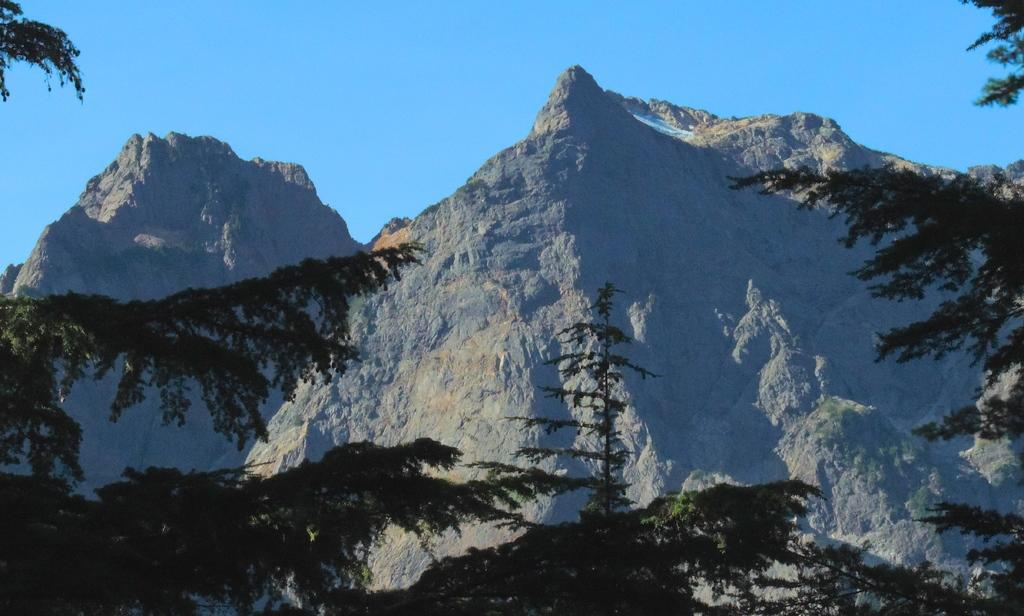What type of vegetation can be seen in the image? There are trees in front of the picture. What geographical feature is visible in the image? There are mountains visible in the image. What part of the natural environment is visible in the background of the image? The sky is visible in the background of the image. What type of wheel can be seen in the image? There is no wheel present in the image. Can you hear the voice of the mountain in the image? There is no voice present in the image, as mountains do not have the ability to produce sound. 